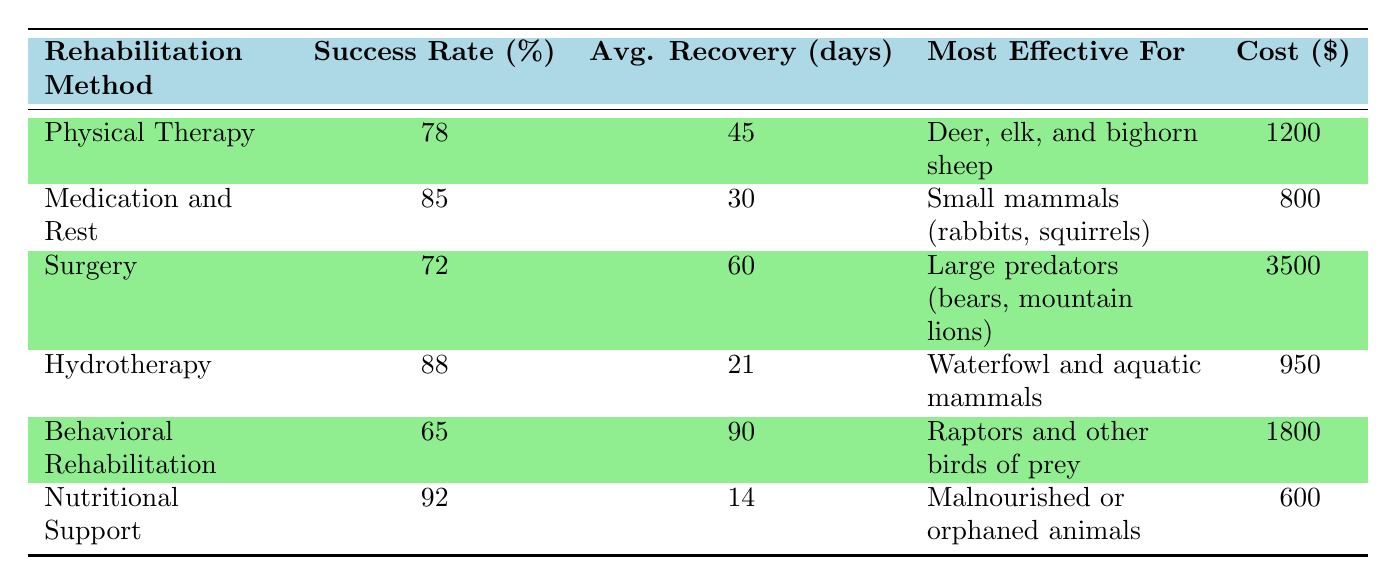What is the success rate of Hydrotherapy? The success rate for Hydrotherapy is specifically stated in the table as 88%.
Answer: 88% Which rehabilitation method has the lowest success rate? By reviewing the success rates listed in the table: 78 (Physical Therapy), 85 (Medication and Rest), 72 (Surgery), 88 (Hydrotherapy), 65 (Behavioral Rehabilitation), and 92 (Nutritional Support). The method with the lowest success rate is Behavioral Rehabilitation at 65%.
Answer: 65% What is the average recovery time for animals rehabilitated using Nutritional Support? The average recovery time for Nutritional Support is listed in the table and is 14 days, taken directly from the data.
Answer: 14 days Which method is the most cost-effective according to the cost per animal? The costs for each method are as follows: 1200 (Physical Therapy), 800 (Medication and Rest), 3500 (Surgery), 950 (Hydrotherapy), 1800 (Behavioral Rehabilitation), and 600 (Nutritional Support). The lowest cost is 600 for Nutritional Support, making it the most cost-effective.
Answer: 600 Are there any rehabilitation methods with a success rate higher than 90%? Looking through the success rates listed, Nutritional Support has a success rate of 92%, which is above 90%. Therefore, yes, there is one method with a success rate higher than 90%.
Answer: Yes What is the average success rate of all rehabilitation methods listed? The success rates to consider are: 78, 85, 72, 88, 65, and 92. First, sum these values: (78 + 85 + 72 + 88 + 65 + 92) = 480. There are 6 methods, so the average is 480 / 6 = 80.
Answer: 80 Which rehabilitation method is the most effective for small mammals? The table clearly identifies "Medication and Rest" as the method most effective for small mammals (rabbits, squirrels), according to the provided data.
Answer: Medication and Rest How long does it typically take for animals to recover when using Surgery? According to the table, the average recovery time when using Surgery is 60 days, which is specified directly in the data.
Answer: 60 days 